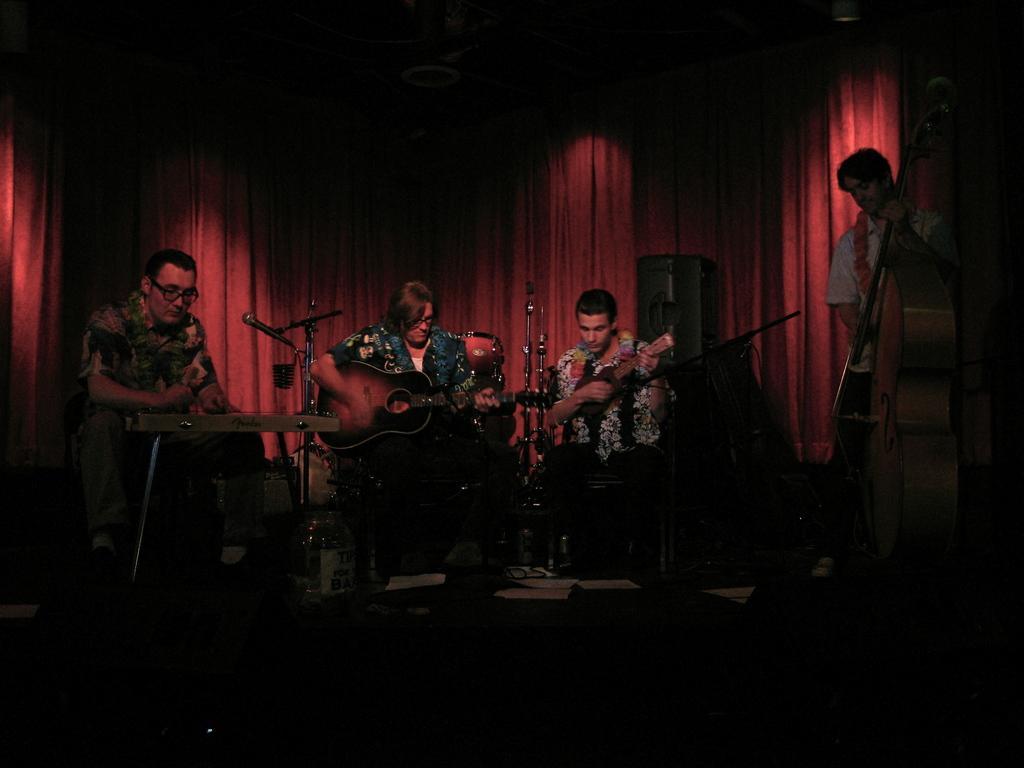Describe this image in one or two sentences. Here there are 4 people on the stage performing by playing musical instruments. Behind them there is a cloth. 